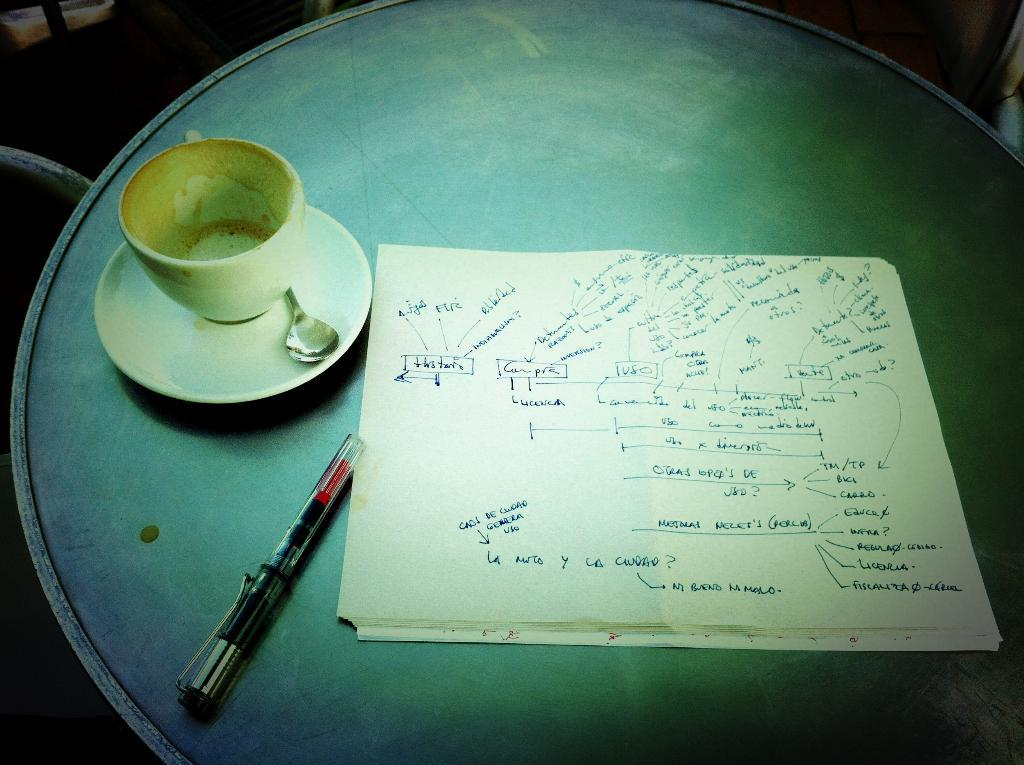What is the primary object with written text in the image? There is a paper with written text in the image. What writing instrument is present in the image? There is a pen in the image. What type of dishware can be seen in the image? There is a cup with saucer in the image. What utensil is visible in the image? There is a spoon in the image. Where are all these objects located? All of these objects are placed on a table. What type of skirt is being discussed by the government in the image? There is no skirt or government mentioned in the image; it features a paper with written text, a pen, a cup with saucer, and a spoon on a table. 